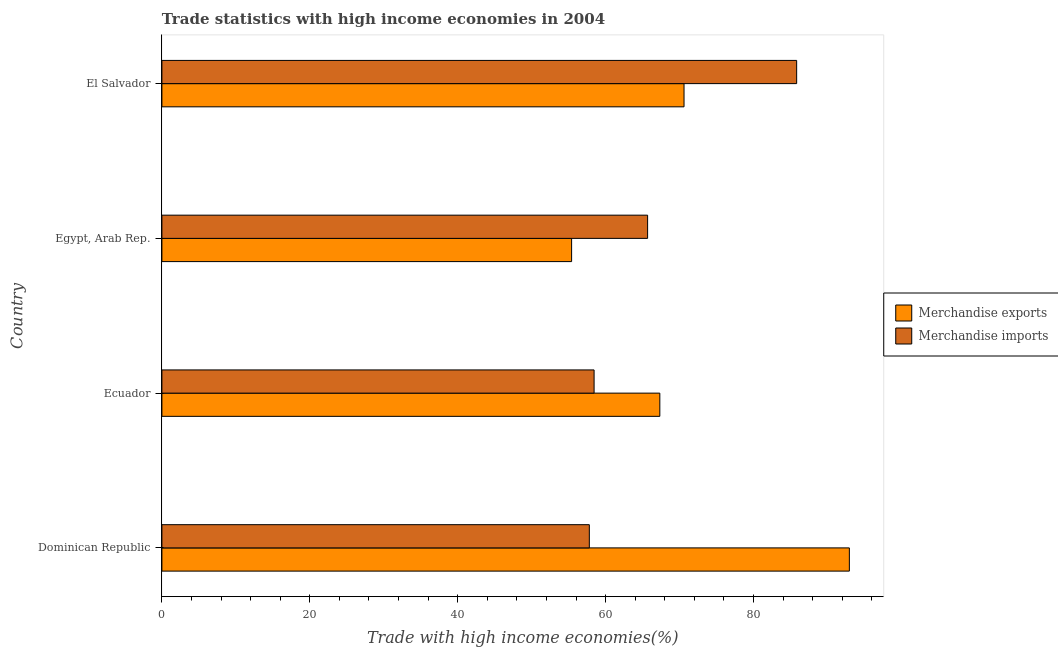Are the number of bars per tick equal to the number of legend labels?
Give a very brief answer. Yes. What is the label of the 2nd group of bars from the top?
Offer a very short reply. Egypt, Arab Rep. In how many cases, is the number of bars for a given country not equal to the number of legend labels?
Give a very brief answer. 0. What is the merchandise exports in Egypt, Arab Rep.?
Keep it short and to the point. 55.4. Across all countries, what is the maximum merchandise imports?
Provide a succinct answer. 85.84. Across all countries, what is the minimum merchandise exports?
Your response must be concise. 55.4. In which country was the merchandise exports maximum?
Ensure brevity in your answer.  Dominican Republic. In which country was the merchandise exports minimum?
Give a very brief answer. Egypt, Arab Rep. What is the total merchandise imports in the graph?
Offer a very short reply. 267.76. What is the difference between the merchandise exports in Ecuador and that in El Salvador?
Your answer should be very brief. -3.27. What is the difference between the merchandise exports in Ecuador and the merchandise imports in El Salvador?
Your answer should be very brief. -18.5. What is the average merchandise exports per country?
Make the answer very short. 71.58. What is the difference between the merchandise exports and merchandise imports in Dominican Republic?
Give a very brief answer. 35.16. What is the ratio of the merchandise imports in Dominican Republic to that in El Salvador?
Your answer should be compact. 0.67. Is the merchandise exports in Dominican Republic less than that in El Salvador?
Offer a very short reply. No. What is the difference between the highest and the second highest merchandise imports?
Your answer should be very brief. 20.16. What is the difference between the highest and the lowest merchandise exports?
Provide a short and direct response. 37.56. In how many countries, is the merchandise imports greater than the average merchandise imports taken over all countries?
Provide a succinct answer. 1. Is the sum of the merchandise imports in Ecuador and El Salvador greater than the maximum merchandise exports across all countries?
Your response must be concise. Yes. Are all the bars in the graph horizontal?
Your answer should be very brief. Yes. How many countries are there in the graph?
Offer a very short reply. 4. What is the difference between two consecutive major ticks on the X-axis?
Offer a terse response. 20. Does the graph contain grids?
Ensure brevity in your answer.  No. How are the legend labels stacked?
Your answer should be very brief. Vertical. What is the title of the graph?
Give a very brief answer. Trade statistics with high income economies in 2004. Does "Start a business" appear as one of the legend labels in the graph?
Your answer should be very brief. No. What is the label or title of the X-axis?
Your answer should be very brief. Trade with high income economies(%). What is the Trade with high income economies(%) in Merchandise exports in Dominican Republic?
Offer a very short reply. 92.96. What is the Trade with high income economies(%) in Merchandise imports in Dominican Republic?
Your answer should be very brief. 57.8. What is the Trade with high income economies(%) in Merchandise exports in Ecuador?
Provide a succinct answer. 67.33. What is the Trade with high income economies(%) in Merchandise imports in Ecuador?
Ensure brevity in your answer.  58.44. What is the Trade with high income economies(%) in Merchandise exports in Egypt, Arab Rep.?
Provide a short and direct response. 55.4. What is the Trade with high income economies(%) of Merchandise imports in Egypt, Arab Rep.?
Offer a very short reply. 65.68. What is the Trade with high income economies(%) in Merchandise exports in El Salvador?
Provide a succinct answer. 70.61. What is the Trade with high income economies(%) in Merchandise imports in El Salvador?
Your answer should be very brief. 85.84. Across all countries, what is the maximum Trade with high income economies(%) in Merchandise exports?
Your answer should be compact. 92.96. Across all countries, what is the maximum Trade with high income economies(%) in Merchandise imports?
Your answer should be very brief. 85.84. Across all countries, what is the minimum Trade with high income economies(%) of Merchandise exports?
Provide a short and direct response. 55.4. Across all countries, what is the minimum Trade with high income economies(%) of Merchandise imports?
Your response must be concise. 57.8. What is the total Trade with high income economies(%) of Merchandise exports in the graph?
Offer a terse response. 286.31. What is the total Trade with high income economies(%) in Merchandise imports in the graph?
Provide a short and direct response. 267.76. What is the difference between the Trade with high income economies(%) of Merchandise exports in Dominican Republic and that in Ecuador?
Your answer should be compact. 25.63. What is the difference between the Trade with high income economies(%) in Merchandise imports in Dominican Republic and that in Ecuador?
Your response must be concise. -0.64. What is the difference between the Trade with high income economies(%) in Merchandise exports in Dominican Republic and that in Egypt, Arab Rep.?
Offer a very short reply. 37.56. What is the difference between the Trade with high income economies(%) in Merchandise imports in Dominican Republic and that in Egypt, Arab Rep.?
Give a very brief answer. -7.88. What is the difference between the Trade with high income economies(%) of Merchandise exports in Dominican Republic and that in El Salvador?
Keep it short and to the point. 22.36. What is the difference between the Trade with high income economies(%) in Merchandise imports in Dominican Republic and that in El Salvador?
Provide a succinct answer. -28.04. What is the difference between the Trade with high income economies(%) of Merchandise exports in Ecuador and that in Egypt, Arab Rep.?
Keep it short and to the point. 11.93. What is the difference between the Trade with high income economies(%) in Merchandise imports in Ecuador and that in Egypt, Arab Rep.?
Offer a very short reply. -7.24. What is the difference between the Trade with high income economies(%) in Merchandise exports in Ecuador and that in El Salvador?
Give a very brief answer. -3.27. What is the difference between the Trade with high income economies(%) of Merchandise imports in Ecuador and that in El Salvador?
Ensure brevity in your answer.  -27.39. What is the difference between the Trade with high income economies(%) in Merchandise exports in Egypt, Arab Rep. and that in El Salvador?
Offer a terse response. -15.2. What is the difference between the Trade with high income economies(%) in Merchandise imports in Egypt, Arab Rep. and that in El Salvador?
Your answer should be compact. -20.16. What is the difference between the Trade with high income economies(%) of Merchandise exports in Dominican Republic and the Trade with high income economies(%) of Merchandise imports in Ecuador?
Offer a terse response. 34.52. What is the difference between the Trade with high income economies(%) in Merchandise exports in Dominican Republic and the Trade with high income economies(%) in Merchandise imports in Egypt, Arab Rep.?
Your response must be concise. 27.28. What is the difference between the Trade with high income economies(%) in Merchandise exports in Dominican Republic and the Trade with high income economies(%) in Merchandise imports in El Salvador?
Provide a succinct answer. 7.12. What is the difference between the Trade with high income economies(%) in Merchandise exports in Ecuador and the Trade with high income economies(%) in Merchandise imports in Egypt, Arab Rep.?
Give a very brief answer. 1.65. What is the difference between the Trade with high income economies(%) in Merchandise exports in Ecuador and the Trade with high income economies(%) in Merchandise imports in El Salvador?
Offer a terse response. -18.5. What is the difference between the Trade with high income economies(%) of Merchandise exports in Egypt, Arab Rep. and the Trade with high income economies(%) of Merchandise imports in El Salvador?
Keep it short and to the point. -30.43. What is the average Trade with high income economies(%) of Merchandise exports per country?
Make the answer very short. 71.58. What is the average Trade with high income economies(%) in Merchandise imports per country?
Provide a short and direct response. 66.94. What is the difference between the Trade with high income economies(%) in Merchandise exports and Trade with high income economies(%) in Merchandise imports in Dominican Republic?
Your answer should be compact. 35.16. What is the difference between the Trade with high income economies(%) in Merchandise exports and Trade with high income economies(%) in Merchandise imports in Ecuador?
Provide a succinct answer. 8.89. What is the difference between the Trade with high income economies(%) in Merchandise exports and Trade with high income economies(%) in Merchandise imports in Egypt, Arab Rep.?
Keep it short and to the point. -10.28. What is the difference between the Trade with high income economies(%) of Merchandise exports and Trade with high income economies(%) of Merchandise imports in El Salvador?
Give a very brief answer. -15.23. What is the ratio of the Trade with high income economies(%) in Merchandise exports in Dominican Republic to that in Ecuador?
Keep it short and to the point. 1.38. What is the ratio of the Trade with high income economies(%) of Merchandise exports in Dominican Republic to that in Egypt, Arab Rep.?
Provide a short and direct response. 1.68. What is the ratio of the Trade with high income economies(%) in Merchandise exports in Dominican Republic to that in El Salvador?
Your response must be concise. 1.32. What is the ratio of the Trade with high income economies(%) in Merchandise imports in Dominican Republic to that in El Salvador?
Give a very brief answer. 0.67. What is the ratio of the Trade with high income economies(%) in Merchandise exports in Ecuador to that in Egypt, Arab Rep.?
Provide a short and direct response. 1.22. What is the ratio of the Trade with high income economies(%) in Merchandise imports in Ecuador to that in Egypt, Arab Rep.?
Offer a terse response. 0.89. What is the ratio of the Trade with high income economies(%) of Merchandise exports in Ecuador to that in El Salvador?
Make the answer very short. 0.95. What is the ratio of the Trade with high income economies(%) in Merchandise imports in Ecuador to that in El Salvador?
Offer a very short reply. 0.68. What is the ratio of the Trade with high income economies(%) in Merchandise exports in Egypt, Arab Rep. to that in El Salvador?
Your answer should be compact. 0.78. What is the ratio of the Trade with high income economies(%) in Merchandise imports in Egypt, Arab Rep. to that in El Salvador?
Ensure brevity in your answer.  0.77. What is the difference between the highest and the second highest Trade with high income economies(%) in Merchandise exports?
Ensure brevity in your answer.  22.36. What is the difference between the highest and the second highest Trade with high income economies(%) of Merchandise imports?
Provide a short and direct response. 20.16. What is the difference between the highest and the lowest Trade with high income economies(%) in Merchandise exports?
Your answer should be compact. 37.56. What is the difference between the highest and the lowest Trade with high income economies(%) of Merchandise imports?
Make the answer very short. 28.04. 